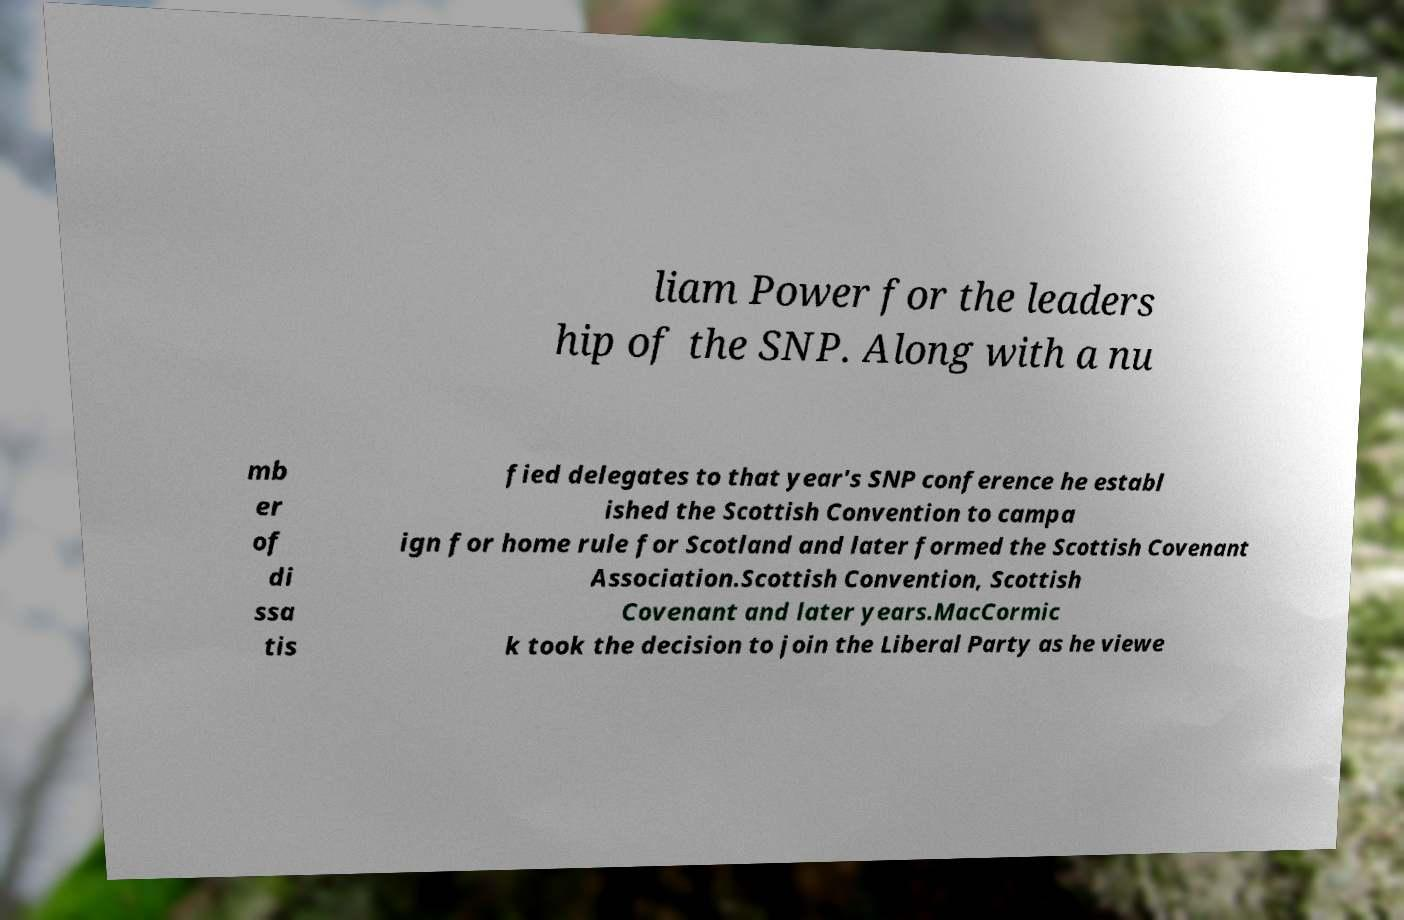Could you assist in decoding the text presented in this image and type it out clearly? liam Power for the leaders hip of the SNP. Along with a nu mb er of di ssa tis fied delegates to that year's SNP conference he establ ished the Scottish Convention to campa ign for home rule for Scotland and later formed the Scottish Covenant Association.Scottish Convention, Scottish Covenant and later years.MacCormic k took the decision to join the Liberal Party as he viewe 